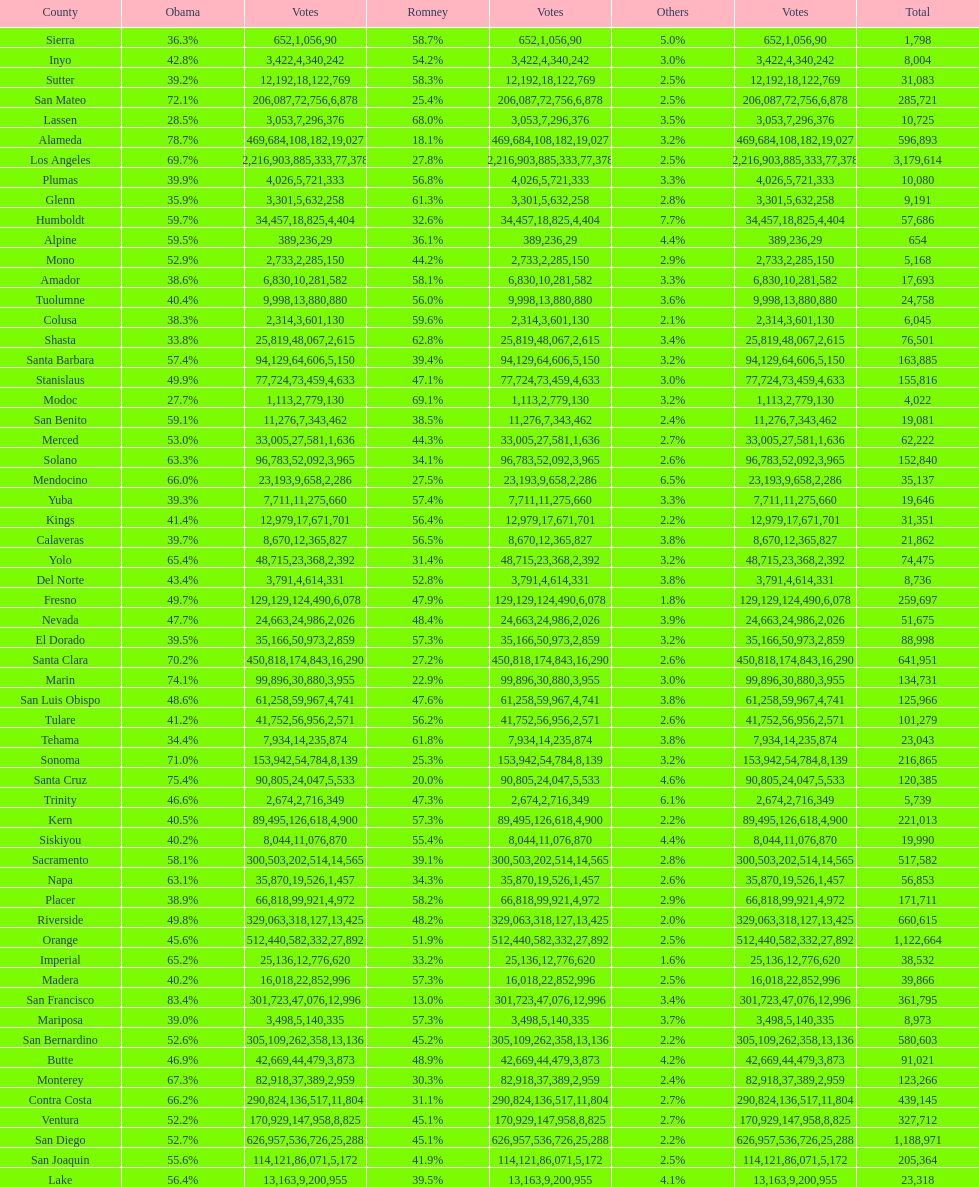Parse the table in full. {'header': ['County', 'Obama', 'Votes', 'Romney', 'Votes', 'Others', 'Votes', 'Total'], 'rows': [['Sierra', '36.3%', '652', '58.7%', '1,056', '5.0%', '90', '1,798'], ['Inyo', '42.8%', '3,422', '54.2%', '4,340', '3.0%', '242', '8,004'], ['Sutter', '39.2%', '12,192', '58.3%', '18,122', '2.5%', '769', '31,083'], ['San Mateo', '72.1%', '206,087', '25.4%', '72,756', '2.5%', '6,878', '285,721'], ['Lassen', '28.5%', '3,053', '68.0%', '7,296', '3.5%', '376', '10,725'], ['Alameda', '78.7%', '469,684', '18.1%', '108,182', '3.2%', '19,027', '596,893'], ['Los Angeles', '69.7%', '2,216,903', '27.8%', '885,333', '2.5%', '77,378', '3,179,614'], ['Plumas', '39.9%', '4,026', '56.8%', '5,721', '3.3%', '333', '10,080'], ['Glenn', '35.9%', '3,301', '61.3%', '5,632', '2.8%', '258', '9,191'], ['Humboldt', '59.7%', '34,457', '32.6%', '18,825', '7.7%', '4,404', '57,686'], ['Alpine', '59.5%', '389', '36.1%', '236', '4.4%', '29', '654'], ['Mono', '52.9%', '2,733', '44.2%', '2,285', '2.9%', '150', '5,168'], ['Amador', '38.6%', '6,830', '58.1%', '10,281', '3.3%', '582', '17,693'], ['Tuolumne', '40.4%', '9,998', '56.0%', '13,880', '3.6%', '880', '24,758'], ['Colusa', '38.3%', '2,314', '59.6%', '3,601', '2.1%', '130', '6,045'], ['Shasta', '33.8%', '25,819', '62.8%', '48,067', '3.4%', '2,615', '76,501'], ['Santa Barbara', '57.4%', '94,129', '39.4%', '64,606', '3.2%', '5,150', '163,885'], ['Stanislaus', '49.9%', '77,724', '47.1%', '73,459', '3.0%', '4,633', '155,816'], ['Modoc', '27.7%', '1,113', '69.1%', '2,779', '3.2%', '130', '4,022'], ['San Benito', '59.1%', '11,276', '38.5%', '7,343', '2.4%', '462', '19,081'], ['Merced', '53.0%', '33,005', '44.3%', '27,581', '2.7%', '1,636', '62,222'], ['Solano', '63.3%', '96,783', '34.1%', '52,092', '2.6%', '3,965', '152,840'], ['Mendocino', '66.0%', '23,193', '27.5%', '9,658', '6.5%', '2,286', '35,137'], ['Yuba', '39.3%', '7,711', '57.4%', '11,275', '3.3%', '660', '19,646'], ['Kings', '41.4%', '12,979', '56.4%', '17,671', '2.2%', '701', '31,351'], ['Calaveras', '39.7%', '8,670', '56.5%', '12,365', '3.8%', '827', '21,862'], ['Yolo', '65.4%', '48,715', '31.4%', '23,368', '3.2%', '2,392', '74,475'], ['Del Norte', '43.4%', '3,791', '52.8%', '4,614', '3.8%', '331', '8,736'], ['Fresno', '49.7%', '129,129', '47.9%', '124,490', '1.8%', '6,078', '259,697'], ['Nevada', '47.7%', '24,663', '48.4%', '24,986', '3.9%', '2,026', '51,675'], ['El Dorado', '39.5%', '35,166', '57.3%', '50,973', '3.2%', '2,859', '88,998'], ['Santa Clara', '70.2%', '450,818', '27.2%', '174,843', '2.6%', '16,290', '641,951'], ['Marin', '74.1%', '99,896', '22.9%', '30,880', '3.0%', '3,955', '134,731'], ['San Luis Obispo', '48.6%', '61,258', '47.6%', '59,967', '3.8%', '4,741', '125,966'], ['Tulare', '41.2%', '41,752', '56.2%', '56,956', '2.6%', '2,571', '101,279'], ['Tehama', '34.4%', '7,934', '61.8%', '14,235', '3.8%', '874', '23,043'], ['Sonoma', '71.0%', '153,942', '25.3%', '54,784', '3.2%', '8,139', '216,865'], ['Santa Cruz', '75.4%', '90,805', '20.0%', '24,047', '4.6%', '5,533', '120,385'], ['Trinity', '46.6%', '2,674', '47.3%', '2,716', '6.1%', '349', '5,739'], ['Kern', '40.5%', '89,495', '57.3%', '126,618', '2.2%', '4,900', '221,013'], ['Siskiyou', '40.2%', '8,044', '55.4%', '11,076', '4.4%', '870', '19,990'], ['Sacramento', '58.1%', '300,503', '39.1%', '202,514', '2.8%', '14,565', '517,582'], ['Napa', '63.1%', '35,870', '34.3%', '19,526', '2.6%', '1,457', '56,853'], ['Placer', '38.9%', '66,818', '58.2%', '99,921', '2.9%', '4,972', '171,711'], ['Riverside', '49.8%', '329,063', '48.2%', '318,127', '2.0%', '13,425', '660,615'], ['Orange', '45.6%', '512,440', '51.9%', '582,332', '2.5%', '27,892', '1,122,664'], ['Imperial', '65.2%', '25,136', '33.2%', '12,776', '1.6%', '620', '38,532'], ['Madera', '40.2%', '16,018', '57.3%', '22,852', '2.5%', '996', '39,866'], ['San Francisco', '83.4%', '301,723', '13.0%', '47,076', '3.4%', '12,996', '361,795'], ['Mariposa', '39.0%', '3,498', '57.3%', '5,140', '3.7%', '335', '8,973'], ['San Bernardino', '52.6%', '305,109', '45.2%', '262,358', '2.2%', '13,136', '580,603'], ['Butte', '46.9%', '42,669', '48.9%', '44,479', '4.2%', '3,873', '91,021'], ['Monterey', '67.3%', '82,918', '30.3%', '37,389', '2.4%', '2,959', '123,266'], ['Contra Costa', '66.2%', '290,824', '31.1%', '136,517', '2.7%', '11,804', '439,145'], ['Ventura', '52.2%', '170,929', '45.1%', '147,958', '2.7%', '8,825', '327,712'], ['San Diego', '52.7%', '626,957', '45.1%', '536,726', '2.2%', '25,288', '1,188,971'], ['San Joaquin', '55.6%', '114,121', '41.9%', '86,071', '2.5%', '5,172', '205,364'], ['Lake', '56.4%', '13,163', '39.5%', '9,200', '4.1%', '955', '23,318']]} Which count had the least number of votes for obama? Modoc. 